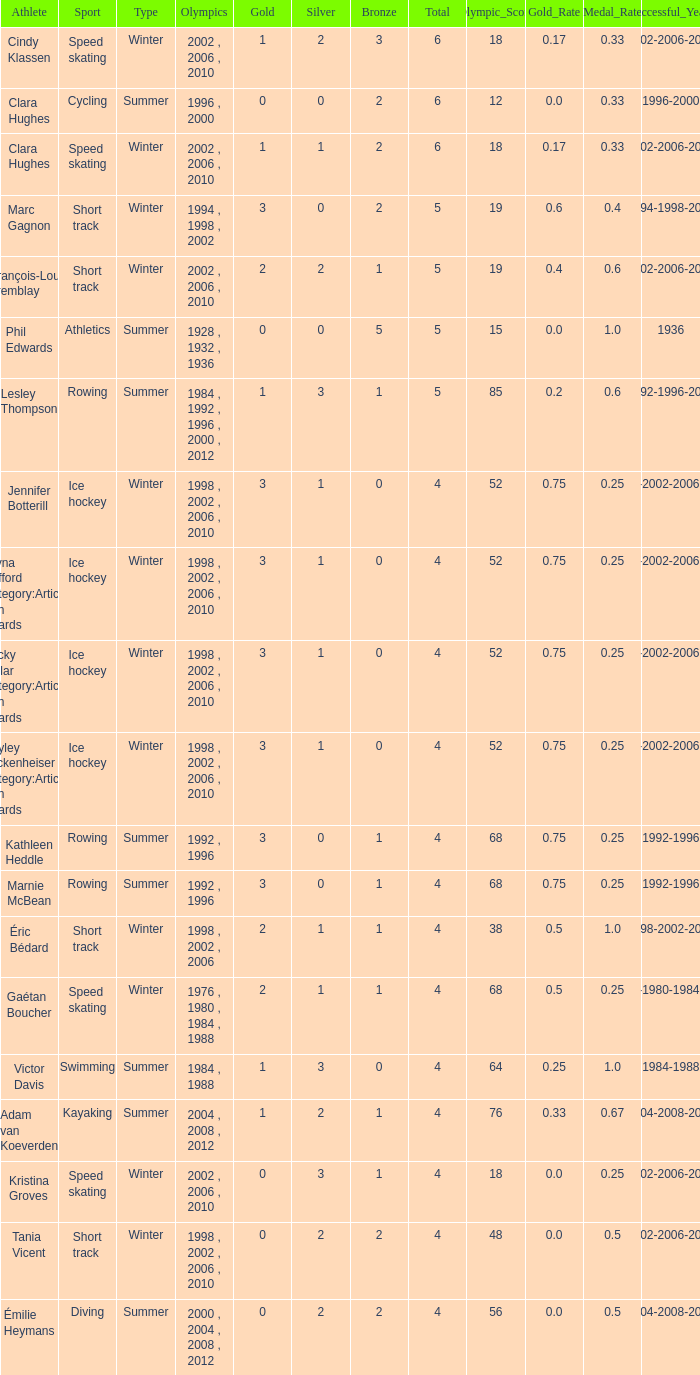What is the lowest number of bronze a short track athlete with 0 gold medals has? 2.0. 